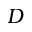<formula> <loc_0><loc_0><loc_500><loc_500>D</formula> 